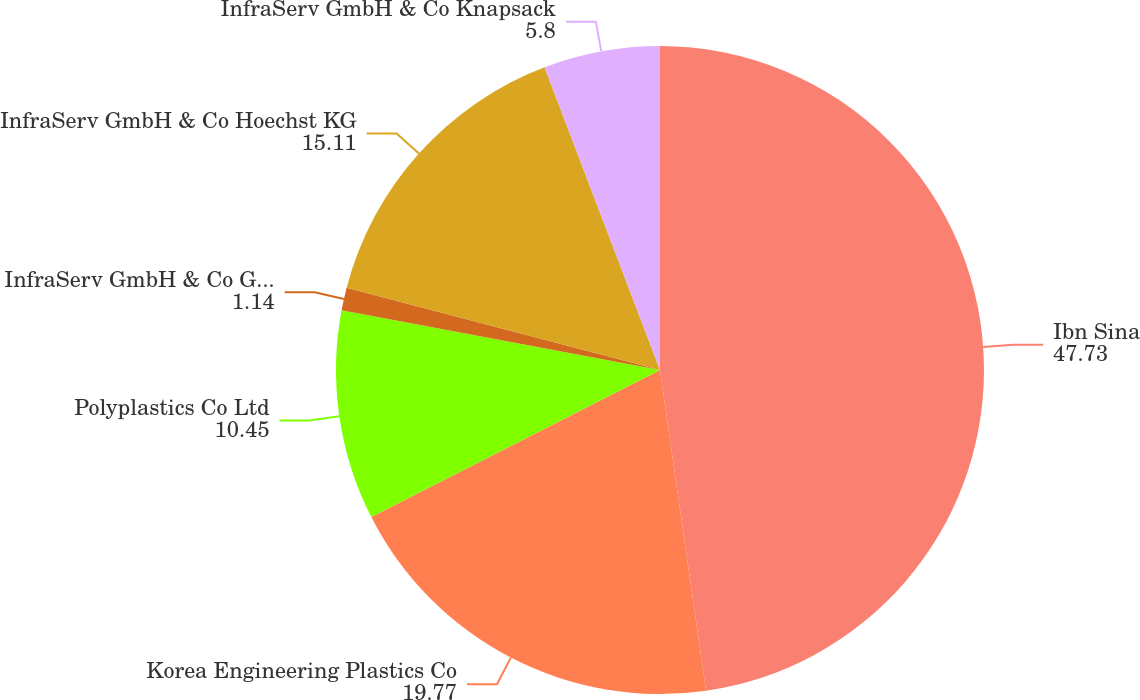Convert chart to OTSL. <chart><loc_0><loc_0><loc_500><loc_500><pie_chart><fcel>Ibn Sina<fcel>Korea Engineering Plastics Co<fcel>Polyplastics Co Ltd<fcel>InfraServ GmbH & Co Gendorf KG<fcel>InfraServ GmbH & Co Hoechst KG<fcel>InfraServ GmbH & Co Knapsack<nl><fcel>47.73%<fcel>19.77%<fcel>10.45%<fcel>1.14%<fcel>15.11%<fcel>5.8%<nl></chart> 